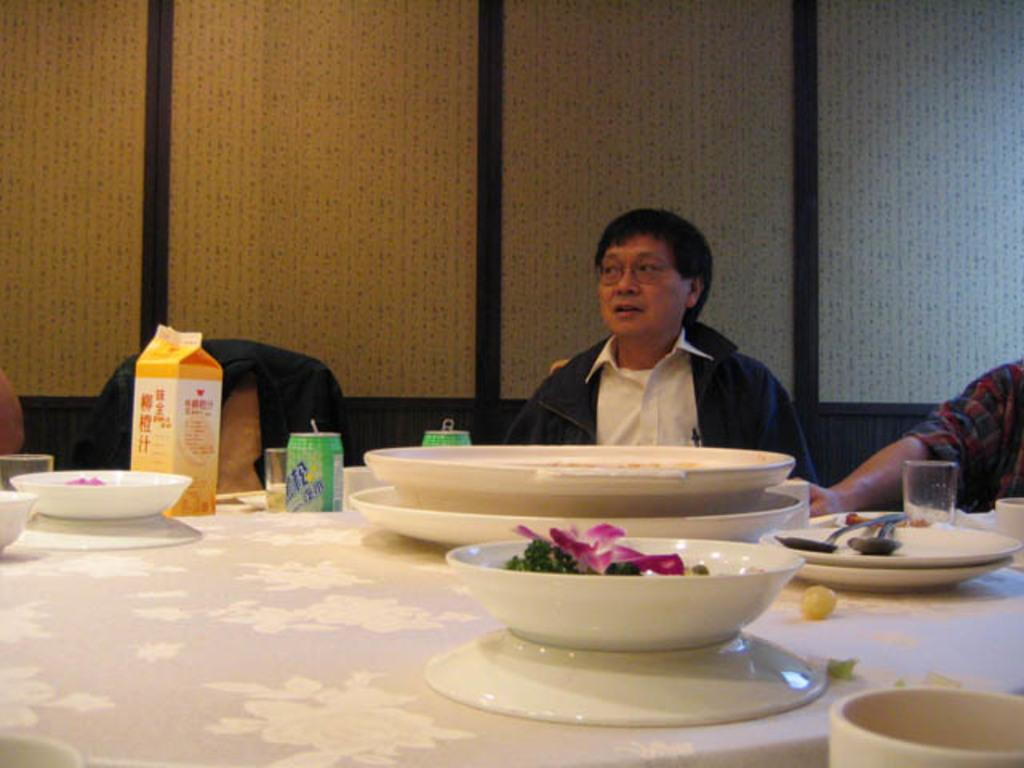How many people are sitting in the chairs in the image? There are two persons sitting on chairs in the image. What is on one of the chairs? There is a jacket on a chair in the image. What can be found on the table in the image? There are food products and utensils on the table in the image. What language is the bird speaking in the image? There is no bird present in the image, so it is not possible to determine the language it might be speaking. 